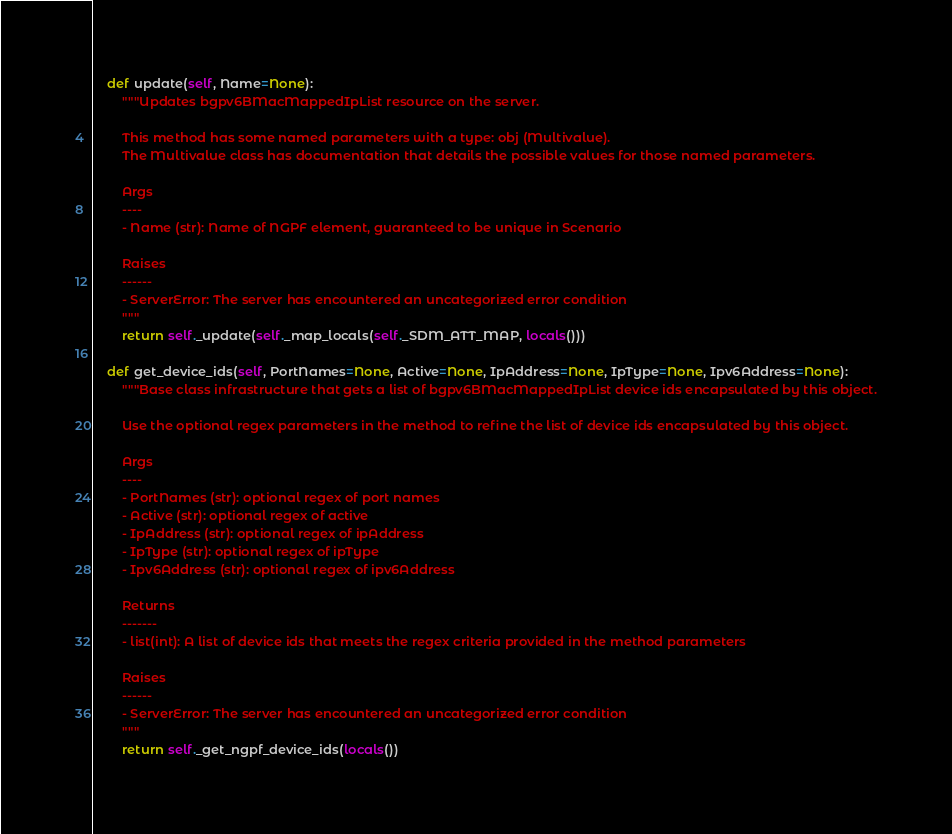Convert code to text. <code><loc_0><loc_0><loc_500><loc_500><_Python_>
    def update(self, Name=None):
        """Updates bgpv6BMacMappedIpList resource on the server.

        This method has some named parameters with a type: obj (Multivalue).
        The Multivalue class has documentation that details the possible values for those named parameters.

        Args
        ----
        - Name (str): Name of NGPF element, guaranteed to be unique in Scenario

        Raises
        ------
        - ServerError: The server has encountered an uncategorized error condition
        """
        return self._update(self._map_locals(self._SDM_ATT_MAP, locals()))

    def get_device_ids(self, PortNames=None, Active=None, IpAddress=None, IpType=None, Ipv6Address=None):
        """Base class infrastructure that gets a list of bgpv6BMacMappedIpList device ids encapsulated by this object.

        Use the optional regex parameters in the method to refine the list of device ids encapsulated by this object.

        Args
        ----
        - PortNames (str): optional regex of port names
        - Active (str): optional regex of active
        - IpAddress (str): optional regex of ipAddress
        - IpType (str): optional regex of ipType
        - Ipv6Address (str): optional regex of ipv6Address

        Returns
        -------
        - list(int): A list of device ids that meets the regex criteria provided in the method parameters

        Raises
        ------
        - ServerError: The server has encountered an uncategorized error condition
        """
        return self._get_ngpf_device_ids(locals())
</code> 